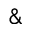<formula> <loc_0><loc_0><loc_500><loc_500>\&</formula> 